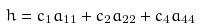Convert formula to latex. <formula><loc_0><loc_0><loc_500><loc_500>h = c _ { 1 } a _ { 1 1 } + c _ { 2 } a _ { 2 2 } + c _ { 4 } a _ { 4 4 }</formula> 